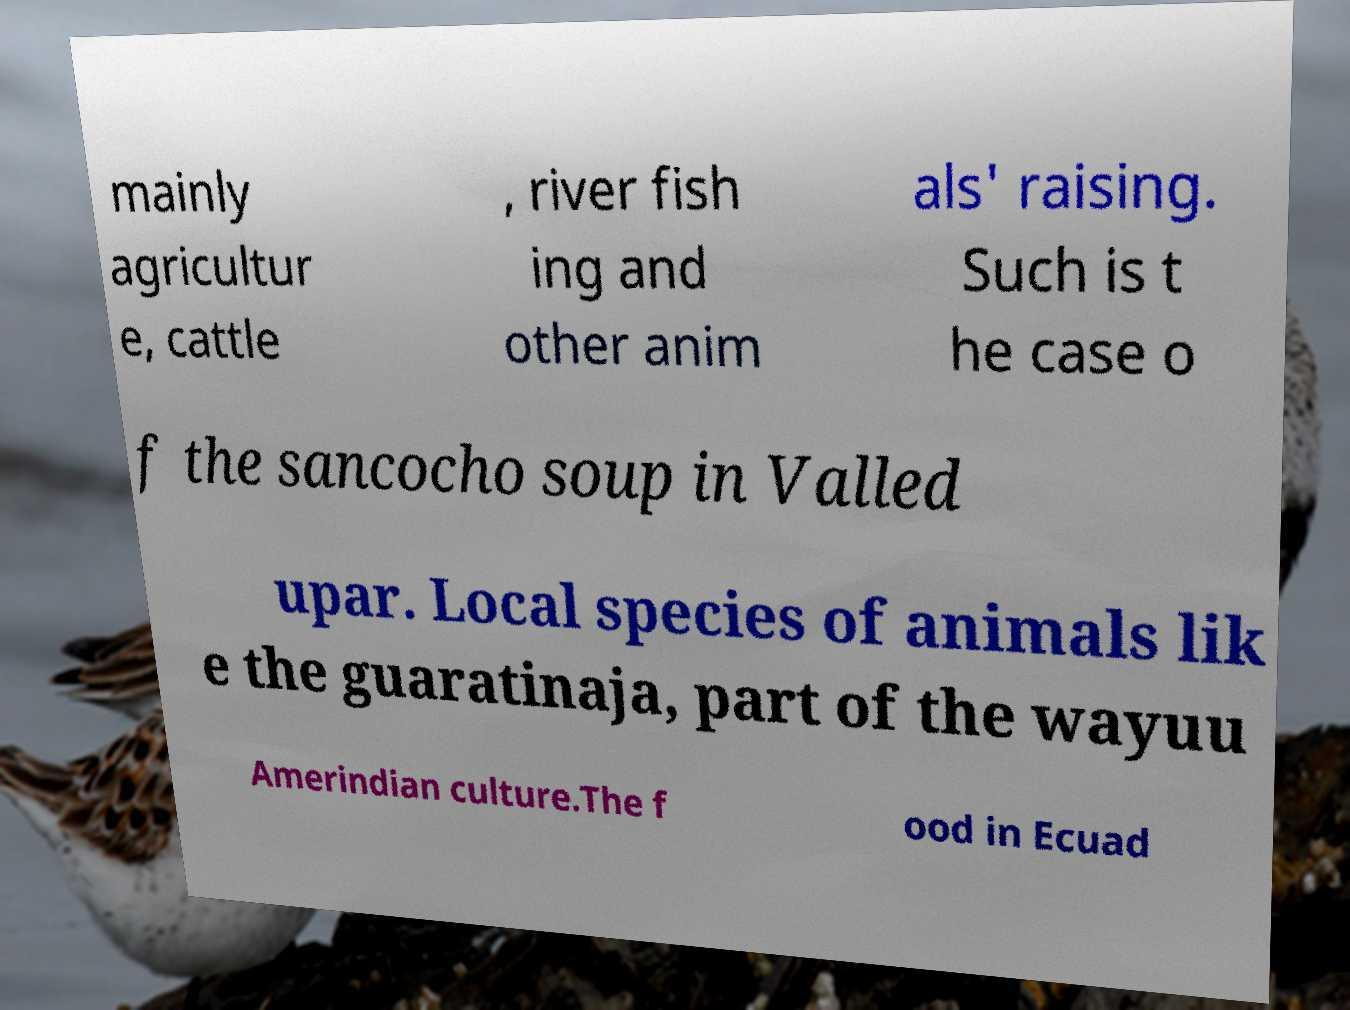Can you read and provide the text displayed in the image?This photo seems to have some interesting text. Can you extract and type it out for me? mainly agricultur e, cattle , river fish ing and other anim als' raising. Such is t he case o f the sancocho soup in Valled upar. Local species of animals lik e the guaratinaja, part of the wayuu Amerindian culture.The f ood in Ecuad 